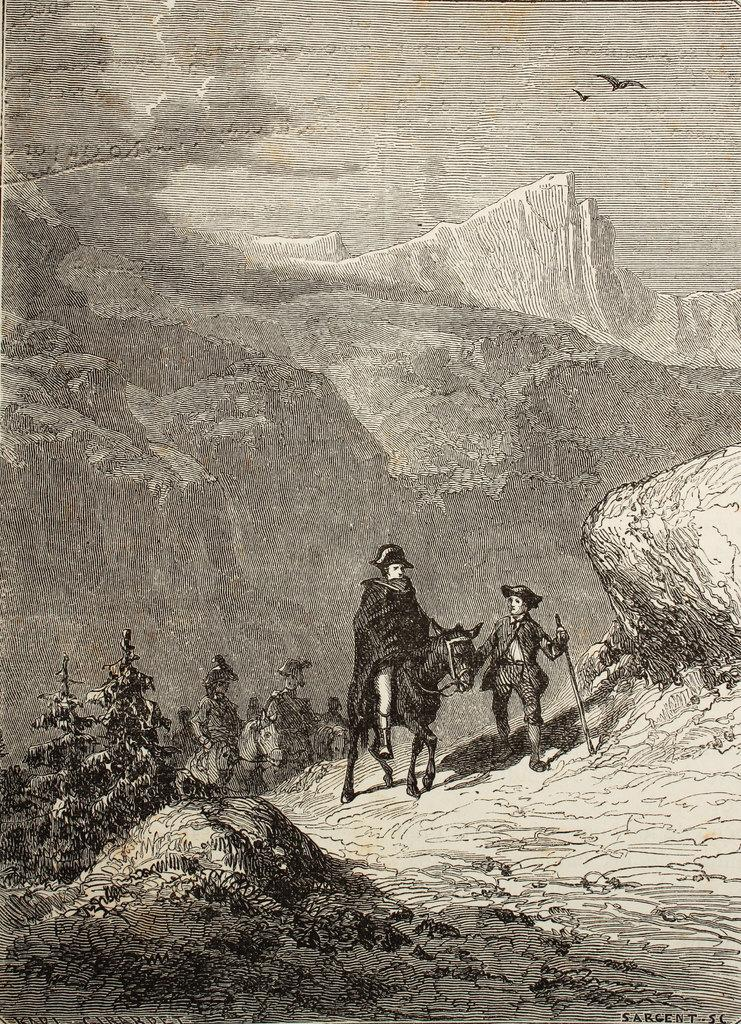What is the main subject of the painting? The painting contains people. What type of environment is depicted in the painting? The painting depicts a landscape with horses. What geographical features are present in the painting? The painting includes mountains. What type of animals are included in the painting? The painting features birds. What part of the natural environment is visible in the painting? The painting includes the sky. How does the painting draw the attention of dirt in the image? The painting does not involve drawing the attention of dirt; it is a visual artwork depicting people, a landscape, horses, mountains, birds, and the sky. 